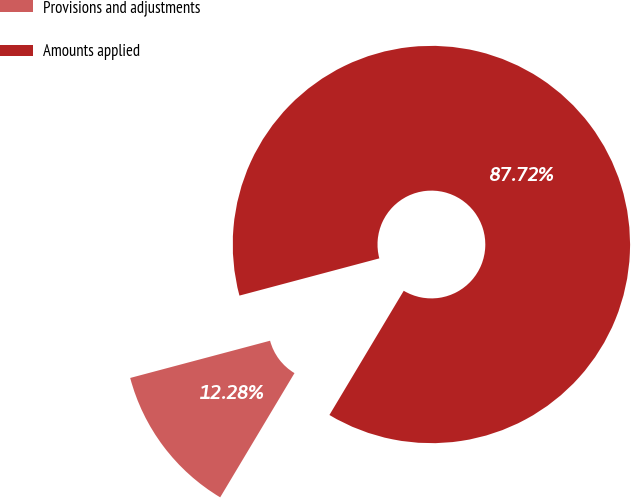Convert chart. <chart><loc_0><loc_0><loc_500><loc_500><pie_chart><fcel>Provisions and adjustments<fcel>Amounts applied<nl><fcel>12.28%<fcel>87.72%<nl></chart> 